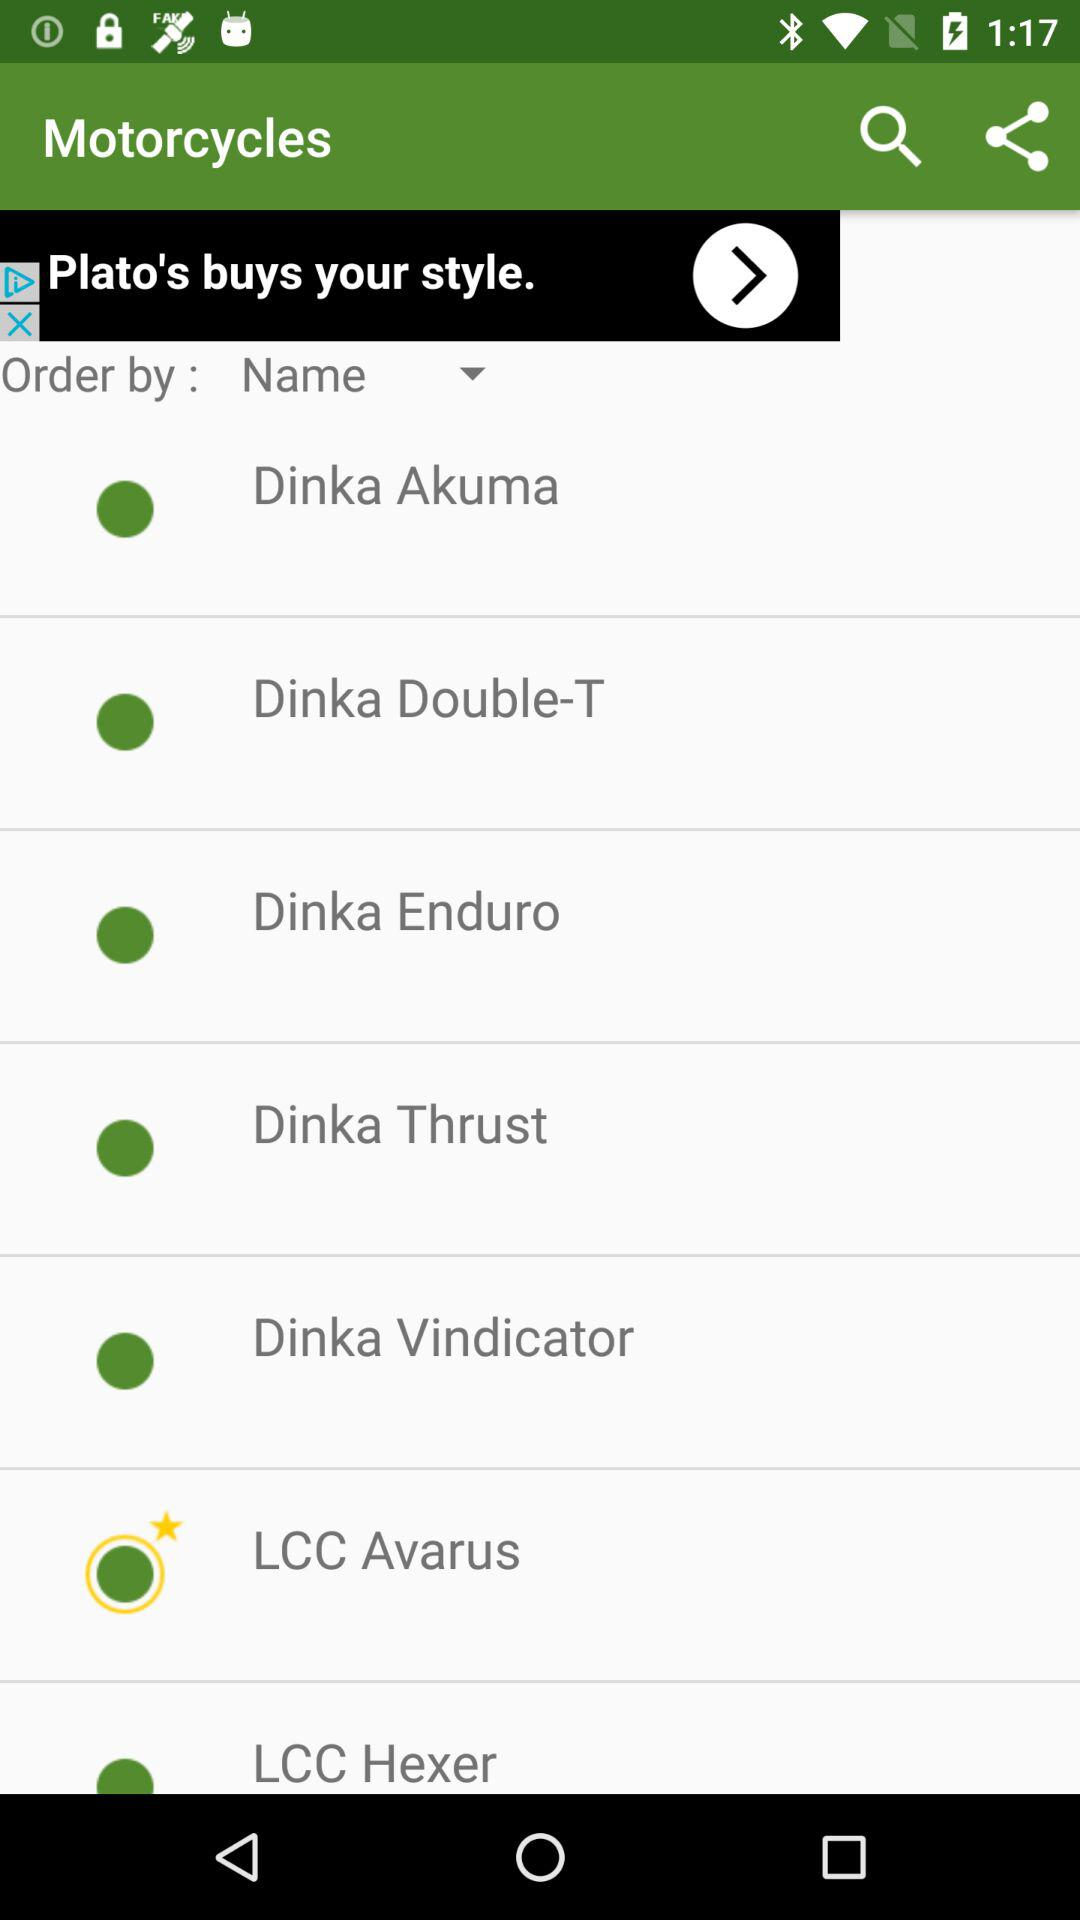What are the different available motorcycle names? The different available motorcycle names are "Dinka Akuma", "Dinka Double-T", "Dinka Enduro", "Dinka Thrust", "Dinka Vindicator", "LCC Avarus" and "LCC Hexer". 